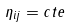Convert formula to latex. <formula><loc_0><loc_0><loc_500><loc_500>\eta _ { i j } = c t e</formula> 